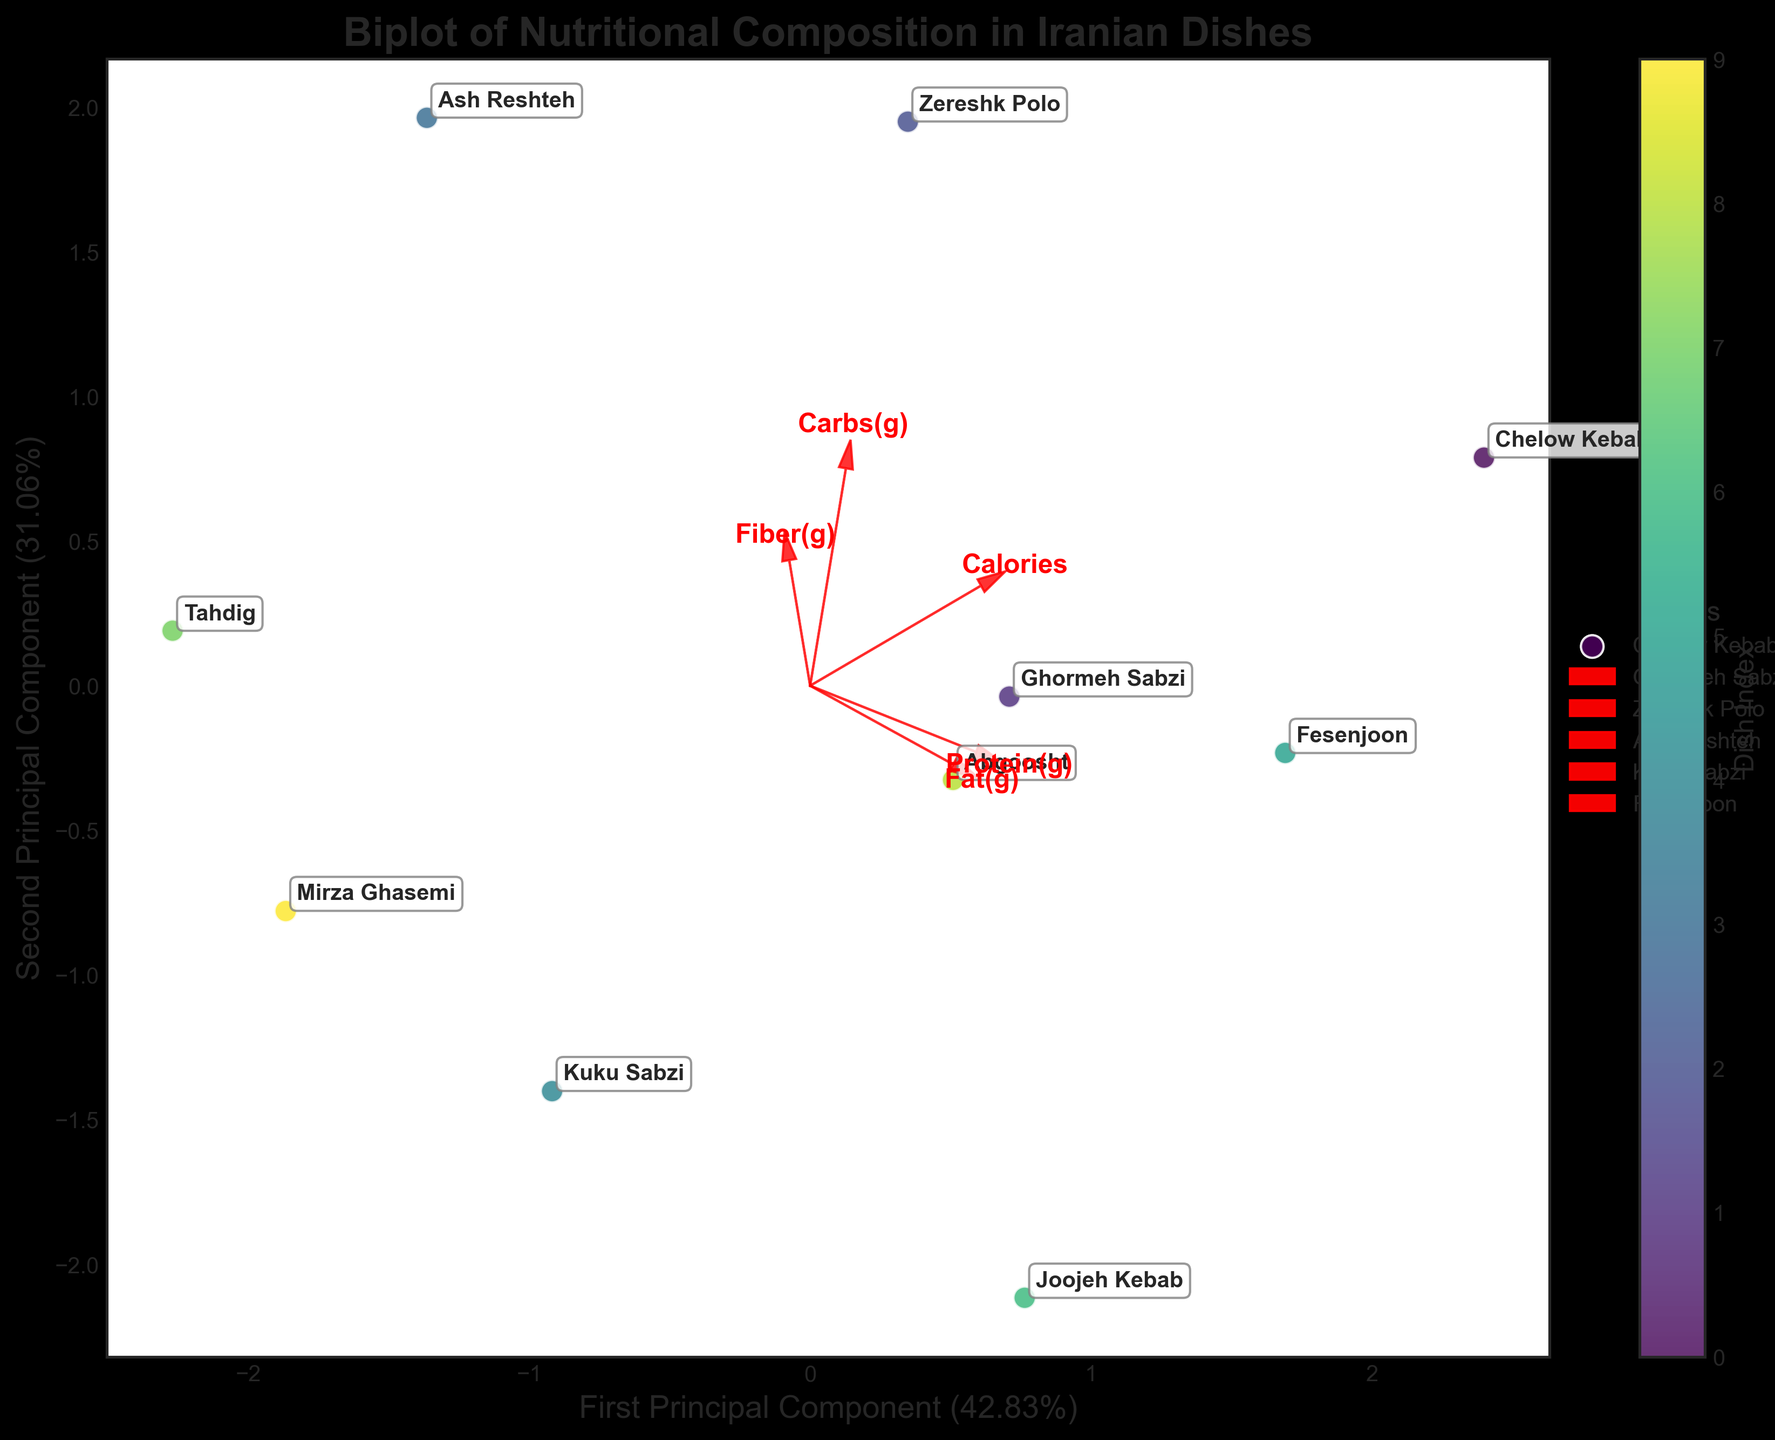What is the title of the biplot? The title is centered at the top of the biplot and indicates the focus of the visual. Titles are typically in a larger and bold font to capture attention and provide context.
Answer: Biplot of Nutritional Composition in Iranian Dishes Which principal component explains the highest variance in the data? Look at the labels on the x and y axes; the principal component with the higher percentage explained variance will be clearly marked.
Answer: First Principal Component Which dish has the highest protein content according to the biplot? Locate the 'Protein(g)' arrow and observe which dish is positioned furthest in the direction of the arrow.
Answer: Joojeh Kebab Which nutrient has the strongest influence on the second principal component? Find the features (arrows) and see which arrow is most aligned with the y-axis, which represents the second principal component.
Answer: Fiber(g) Among 'Ghormeh Sabzi' and 'Zereshk Polo,' which dish has higher caloric content? Look for the positions of both 'Ghormeh Sabzi' and 'Zereshk Polo' on the biplot, and refer to the caloric axis or associated vectors if annotated closely.
Answer: Zereshk Polo Which two dishes appear closest to each other on the biplot? Identify pairs of dishes and compare their distances visually on the plot, noting which pair has the smallest distance between them.
Answer: Mirza Ghasemi and Kuku Sabzi What general trend can be observed regarding 'Fat(g)' content and its impact on dish positioning? Follow the direction of the 'Fat(g)' arrow and see where dishes with higher fat content are positioned relative to this vector.
Answer: Dishes high in fat are positioned in the direction the 'Fat(g)' arrow points How does 'Chelow Kebab' compare to 'Ash Reshteh' in terms of carbohydrate content? Observe the 'Carbs(g)' arrow and compare the proximity of 'Chelow Kebab' and 'Ash Reshteh' to it; the closer dish to the arrow has higher carbohydrate content.
Answer: Chelow Kebab has more carbs Which dish is more aligned with the 'Calories' vector, 'Fesenjoon' or 'Abgoosht'? Look at the positions of 'Fesenjoon' and 'Abgoosht' relative to the 'Calories' vector, and see which is more closely aligned.
Answer: Fesenjoon What is the position of 'Joojeh Kebab' on the plot in terms of both principal components? Locate 'Joojeh Kebab' on the biplot and identify its coordinates relative to the x-axis (first principal component) and y-axis (second principal component).
Answer: Approximately (positive, negative) 